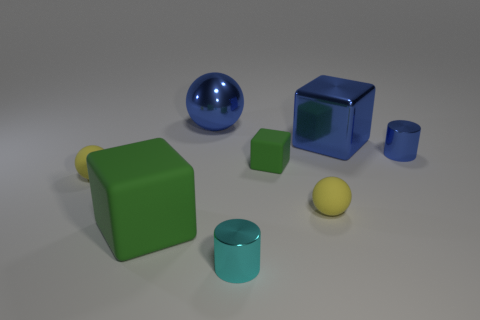Add 1 yellow balls. How many objects exist? 9 Subtract all spheres. How many objects are left? 5 Subtract all small cyan objects. Subtract all big blue shiny blocks. How many objects are left? 6 Add 8 big balls. How many big balls are left? 9 Add 8 small red shiny blocks. How many small red shiny blocks exist? 8 Subtract 0 cyan cubes. How many objects are left? 8 